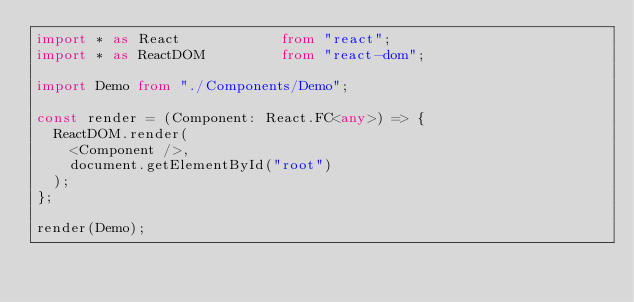Convert code to text. <code><loc_0><loc_0><loc_500><loc_500><_TypeScript_>import * as React            from "react";
import * as ReactDOM         from "react-dom";

import Demo from "./Components/Demo";

const render = (Component: React.FC<any>) => {
	ReactDOM.render(
		<Component />,
		document.getElementById("root")
	);
};

render(Demo);</code> 